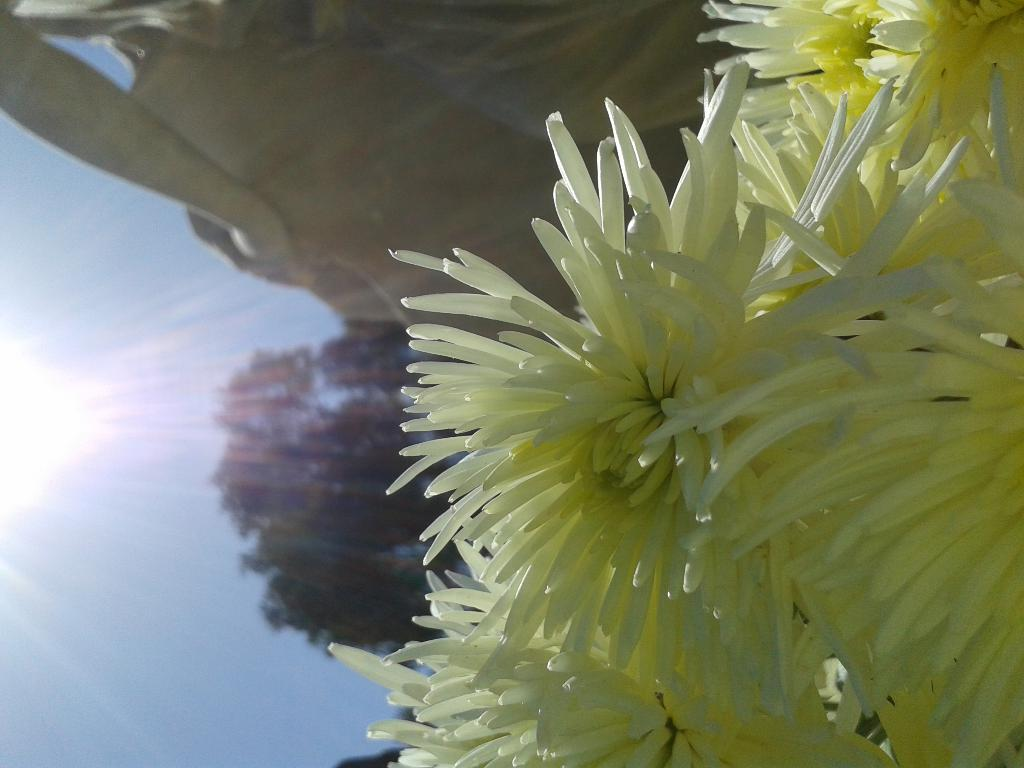What type of floral arrangement is present in the image? There is a bunch of flowers in the image. What other objects or structures can be seen in the image? There is a statue visible in the image. What type of plant is also present in the image? There is a tree in the image. What can be seen in the background of the image? The sky is visible in the image. Where is the gun located in the image? There is no gun present in the image. Can you describe the window in the image? There is no window present in the image. 